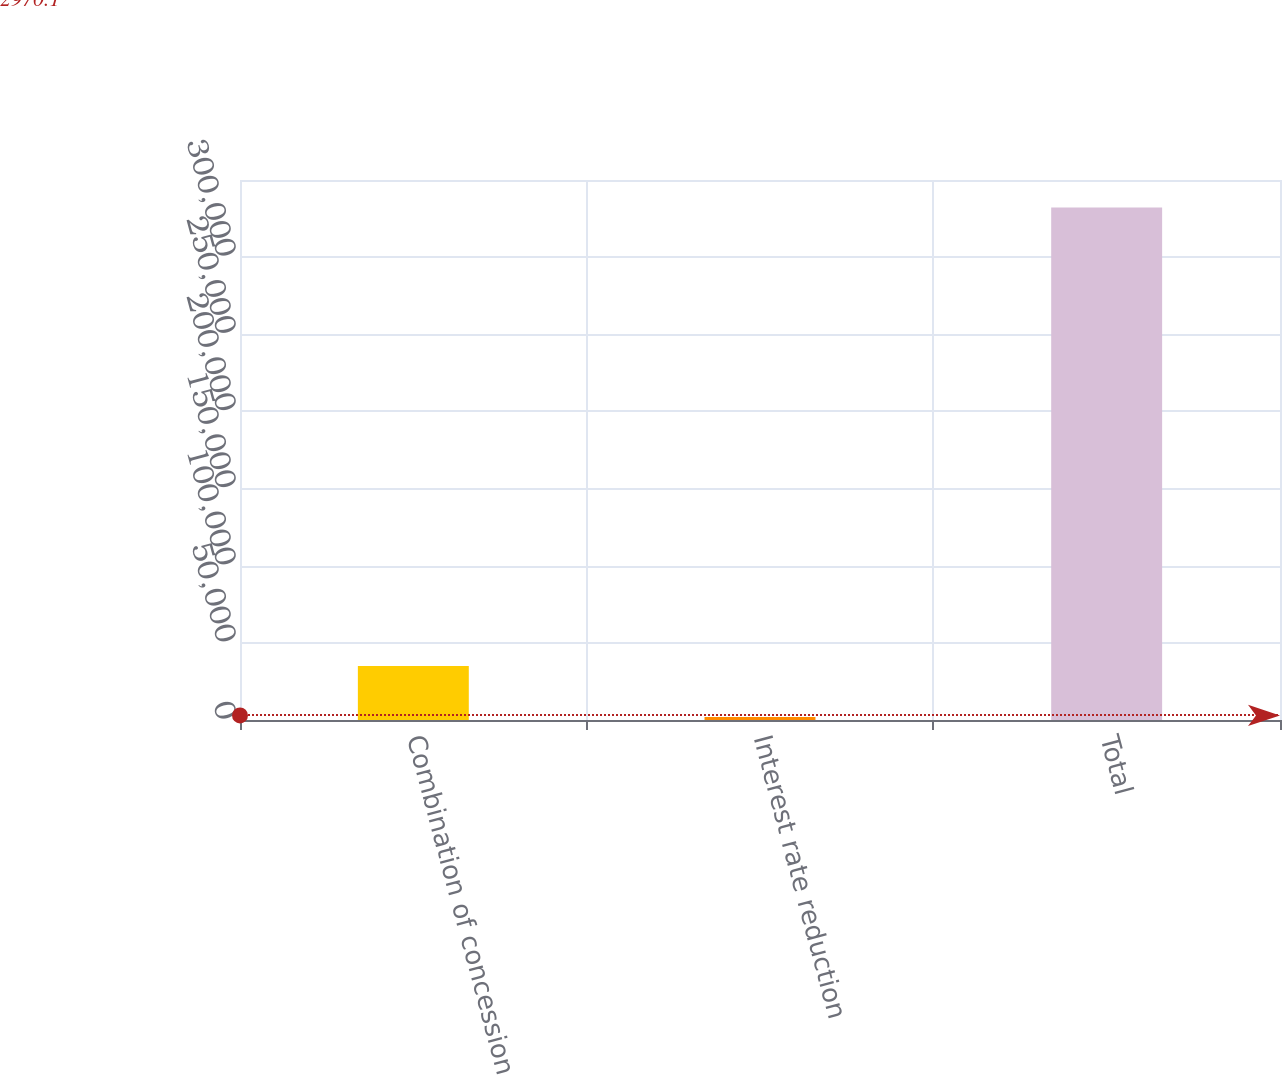Convert chart. <chart><loc_0><loc_0><loc_500><loc_500><bar_chart><fcel>Combination of concession<fcel>Interest rate reduction<fcel>Total<nl><fcel>34949.4<fcel>1926<fcel>332160<nl></chart> 